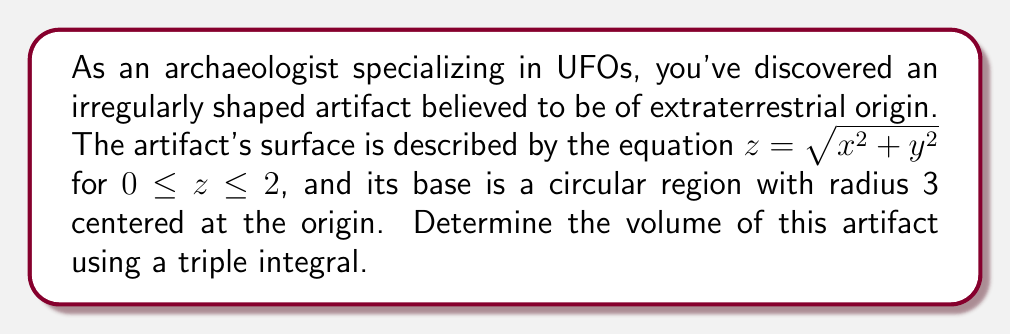Teach me how to tackle this problem. To find the volume of this irregularly shaped artifact, we'll use a triple integral in cylindrical coordinates. Here's the step-by-step solution:

1) First, let's identify the limits of integration:
   $r$: from 0 to 3 (radius of the base)
   $\theta$: from 0 to $2\pi$ (full circular base)
   $z$: from 0 to $\sqrt{x^2 + y^2}$ (surface equation)

2) The volume integral in cylindrical coordinates is:
   $$V = \int_0^{2\pi} \int_0^3 \int_0^{\sqrt{r^2}} r \, dz \, dr \, d\theta$$

3) Let's evaluate the innermost integral first:
   $$\int_0^{\sqrt{r^2}} r \, dz = r[z]_0^{\sqrt{r^2}} = r\sqrt{r^2} - 0 = r^2$$

4) Now our double integral becomes:
   $$V = \int_0^{2\pi} \int_0^3 r^2 \, dr \, d\theta$$

5) Evaluate the integral with respect to $r$:
   $$\int_0^3 r^2 \, dr = [\frac{1}{3}r^3]_0^3 = 9$$

6) Our final integral is:
   $$V = \int_0^{2\pi} 9 \, d\theta = 9[θ]_0^{2\pi} = 18\pi$$

Therefore, the volume of the artifact is $18\pi$ cubic units.
Answer: $18\pi$ cubic units 